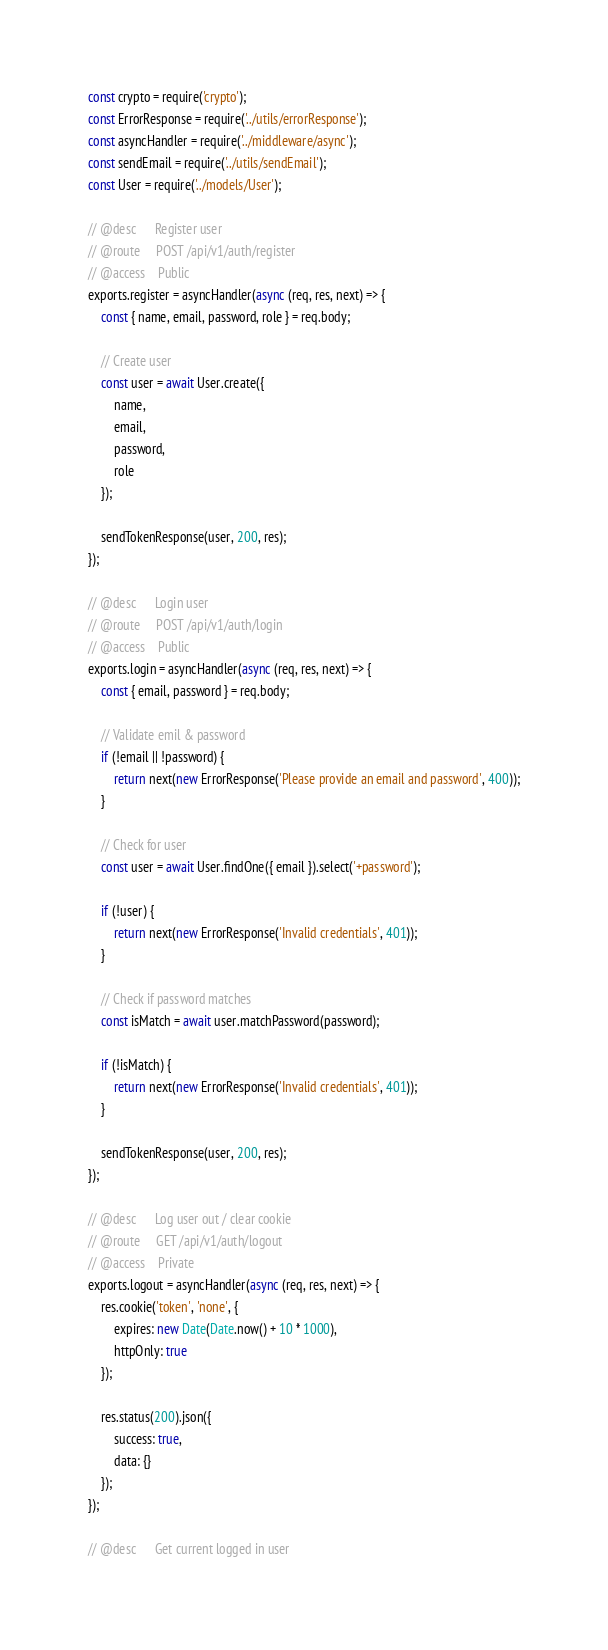<code> <loc_0><loc_0><loc_500><loc_500><_JavaScript_>const crypto = require('crypto');
const ErrorResponse = require('../utils/errorResponse');
const asyncHandler = require('../middleware/async');
const sendEmail = require('../utils/sendEmail');
const User = require('../models/User');

// @desc      Register user
// @route     POST /api/v1/auth/register
// @access    Public
exports.register = asyncHandler(async (req, res, next) => {
    const { name, email, password, role } = req.body;

    // Create user
    const user = await User.create({
        name,
        email,
        password,
        role
    });

    sendTokenResponse(user, 200, res);
});

// @desc      Login user
// @route     POST /api/v1/auth/login
// @access    Public
exports.login = asyncHandler(async (req, res, next) => {
    const { email, password } = req.body;

    // Validate emil & password
    if (!email || !password) {
        return next(new ErrorResponse('Please provide an email and password', 400));
    }

    // Check for user
    const user = await User.findOne({ email }).select('+password');

    if (!user) {
        return next(new ErrorResponse('Invalid credentials', 401));
    }

    // Check if password matches
    const isMatch = await user.matchPassword(password);

    if (!isMatch) {
        return next(new ErrorResponse('Invalid credentials', 401));
    }

    sendTokenResponse(user, 200, res);
});

// @desc      Log user out / clear cookie
// @route     GET /api/v1/auth/logout
// @access    Private
exports.logout = asyncHandler(async (req, res, next) => {
    res.cookie('token', 'none', {
        expires: new Date(Date.now() + 10 * 1000),
        httpOnly: true
    });

    res.status(200).json({
        success: true,
        data: {}
    });
});

// @desc      Get current logged in user</code> 